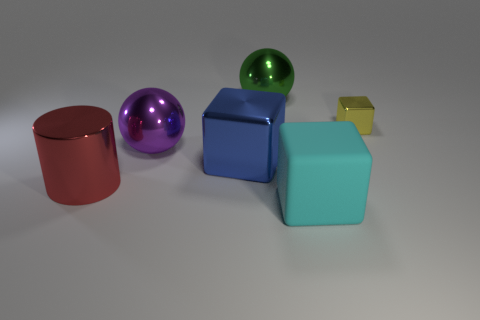What is the shape of the red thing that is the same material as the blue thing?
Provide a succinct answer. Cylinder. There is a blue shiny cube; does it have the same size as the metal block behind the purple sphere?
Offer a terse response. No. What is the shape of the large purple object that is on the left side of the large shiny object that is behind the sphere that is in front of the small yellow metallic object?
Keep it short and to the point. Sphere. Are there fewer blue shiny blocks than green matte cubes?
Your answer should be very brief. No. There is a rubber object; are there any blocks behind it?
Provide a succinct answer. Yes. There is a shiny object that is behind the purple thing and left of the small yellow metal block; what shape is it?
Provide a succinct answer. Sphere. Is there another large purple object of the same shape as the big matte thing?
Ensure brevity in your answer.  No. There is a shiny sphere that is in front of the green thing; does it have the same size as the metallic cube right of the blue shiny cube?
Your answer should be compact. No. Is the number of big green objects greater than the number of large balls?
Give a very brief answer. No. What number of gray things have the same material as the green sphere?
Offer a terse response. 0. 